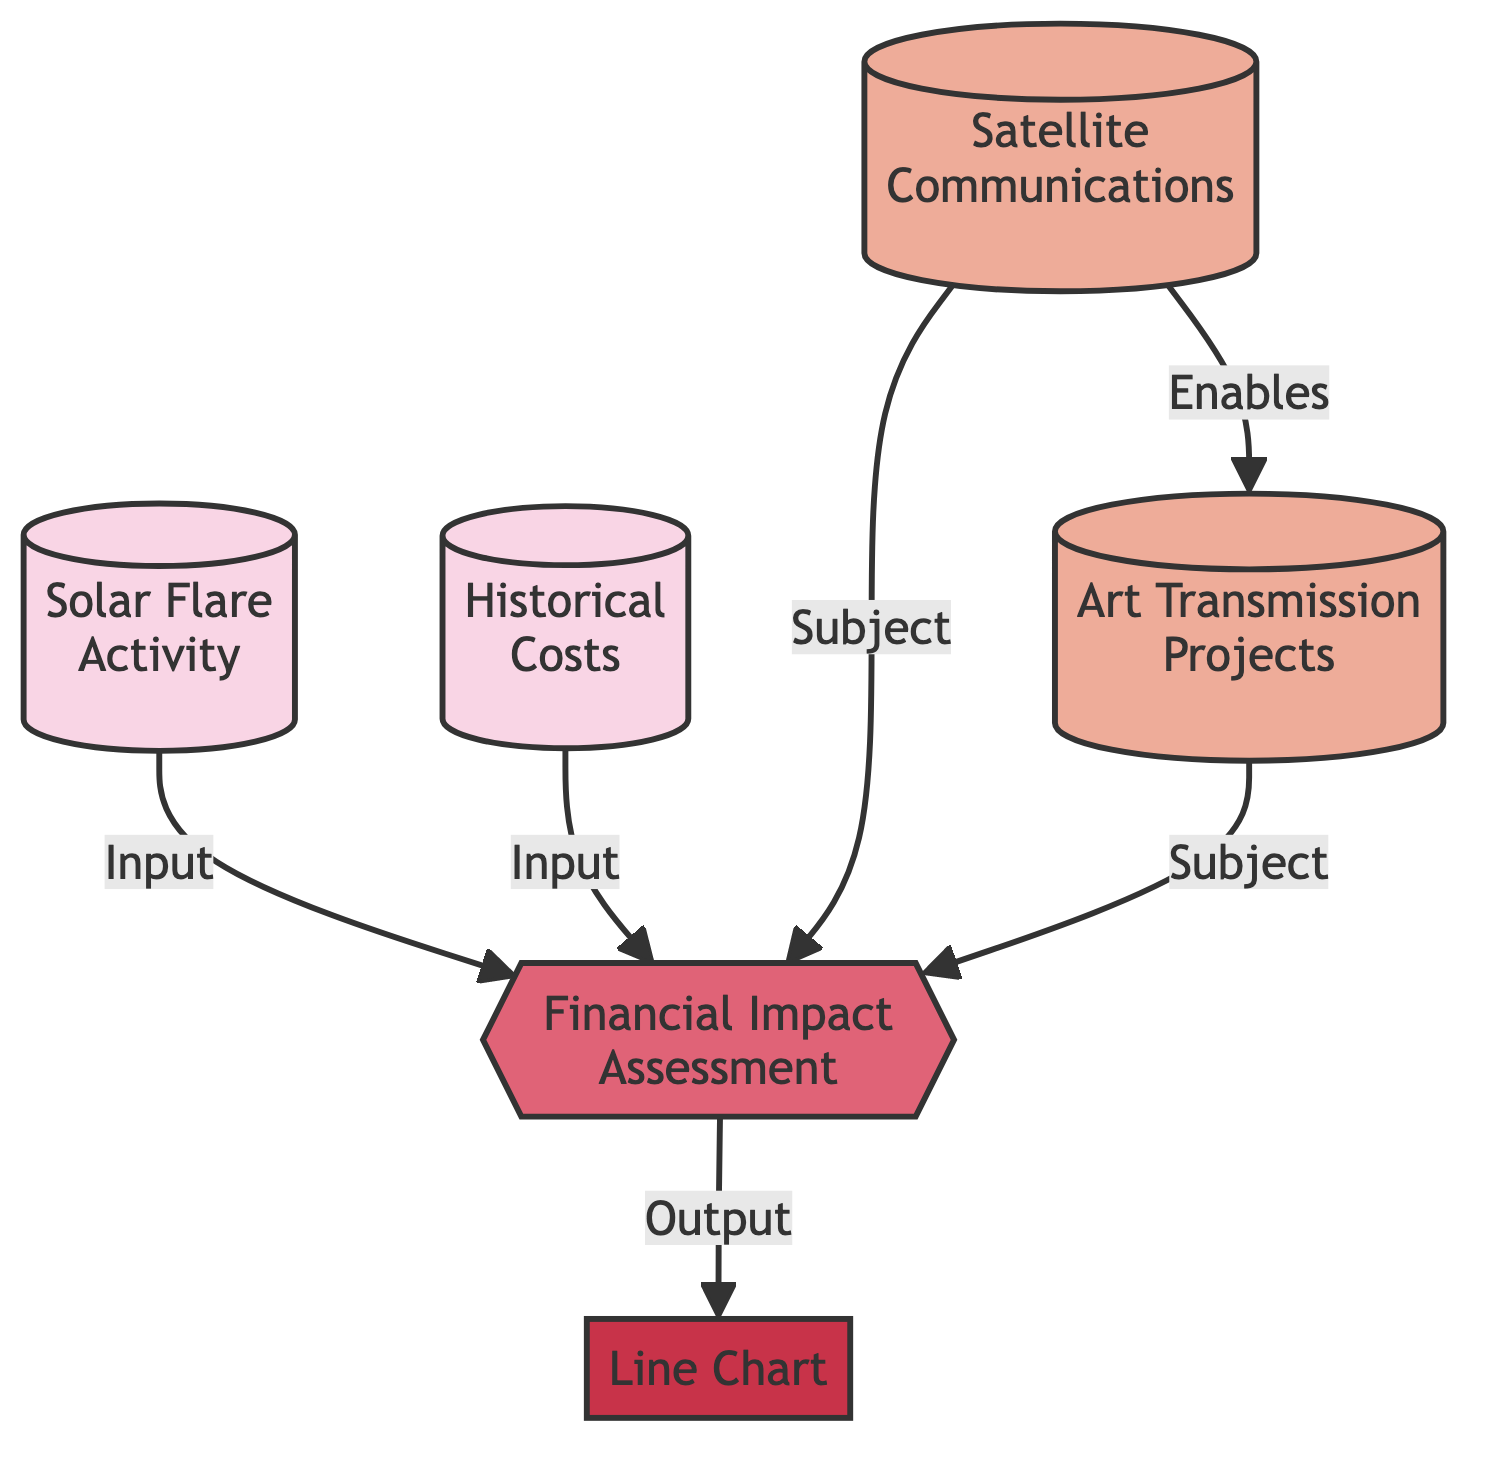What are the two data sources used for financial impact assessment? The diagram shows two data sources: "Solar Flare Activity" and "Historical Costs," which provide input to the "Financial Impact Assessment" process.
Answer: Solar Flare Activity, Historical Costs What is the output of the financial impact assessment? The "Financial Impact Assessment" process outputs a "Line Chart," representing the relationship between historical solar flare activity and associated costs.
Answer: Line Chart How many entities are represented in the diagram? The diagram has two entities: "Satellite Communications" and "Art Transmission Projects." These entities relate to the financial impact assessment.
Answer: 2 Which node enables art transmission projects? The "Satellite Communications" node enables "Art Transmission Projects," indicating that the ability to communicate through satellites directly impacts how art can be transmitted.
Answer: Satellite Communications What is the role of financial impact assessment in the diagram? The "Financial Impact Assessment" acts as a process that receives data from the two sources and produces an output visualizing this information, showing its central role in understanding costs related to solar flare activity.
Answer: Process How many relationships are indicated in the diagram? The diagram shows five relationships, as indicated by the arrows connecting nodes. Each relationship signifies how different elements impact the overall assessment.
Answer: 5 What type of diagram is represented here? The structure presented in the diagram is a flowchart, which outlines processes and relationships between different components in the context of financial risk assessment.
Answer: Flowchart 